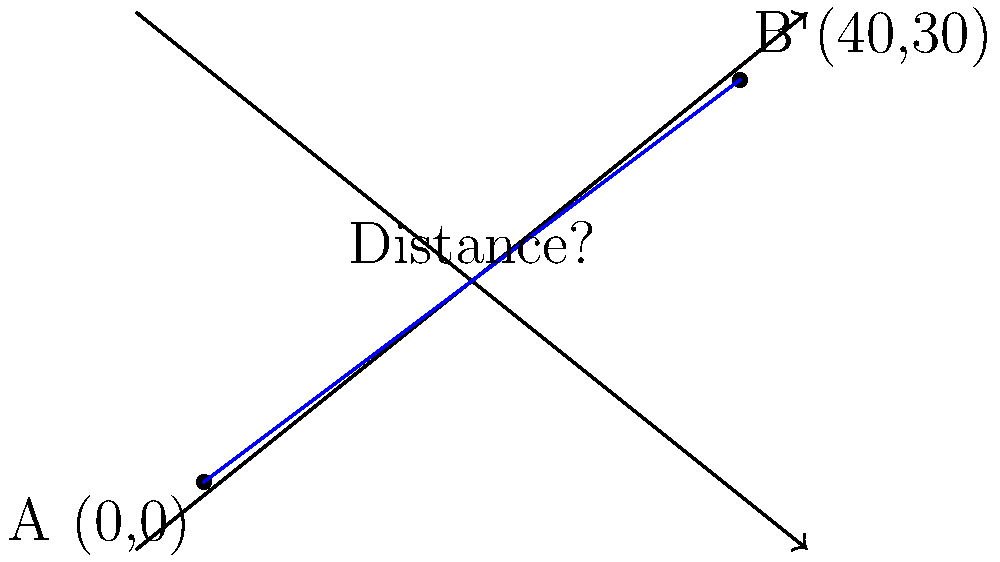During a practice session, you notice two players, A and B, positioned on the field. Player A is at the origin (0,0), and Player B is at coordinates (40,30) on your coordinate grid, where each unit represents 1 yard. Using the distance formula, calculate the straight-line distance between these two players to the nearest yard. To solve this problem, we'll use the distance formula:

$$d = \sqrt{(x_2-x_1)^2 + (y_2-y_1)^2}$$

Where $(x_1,y_1)$ is the position of Player A and $(x_2,y_2)$ is the position of Player B.

Step 1: Identify the coordinates
Player A: $(x_1,y_1) = (0,0)$
Player B: $(x_2,y_2) = (40,30)$

Step 2: Plug the values into the distance formula
$$d = \sqrt{(40-0)^2 + (30-0)^2}$$

Step 3: Simplify
$$d = \sqrt{40^2 + 30^2}$$
$$d = \sqrt{1600 + 900}$$
$$d = \sqrt{2500}$$

Step 4: Calculate the square root
$$d = 50$$

Therefore, the distance between the two players is 50 yards.
Answer: 50 yards 